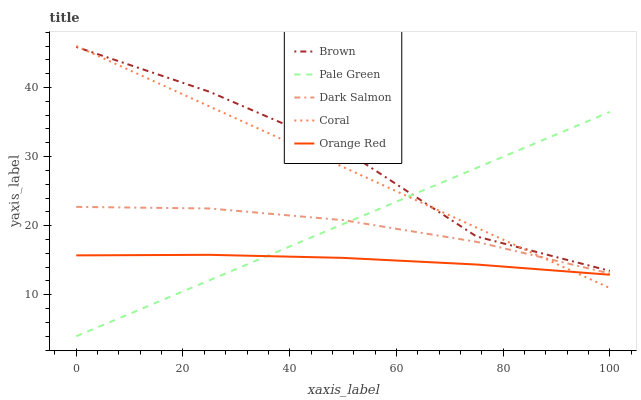Does Orange Red have the minimum area under the curve?
Answer yes or no. Yes. Does Brown have the maximum area under the curve?
Answer yes or no. Yes. Does Coral have the minimum area under the curve?
Answer yes or no. No. Does Coral have the maximum area under the curve?
Answer yes or no. No. Is Pale Green the smoothest?
Answer yes or no. Yes. Is Brown the roughest?
Answer yes or no. Yes. Is Coral the smoothest?
Answer yes or no. No. Is Coral the roughest?
Answer yes or no. No. Does Pale Green have the lowest value?
Answer yes or no. Yes. Does Coral have the lowest value?
Answer yes or no. No. Does Coral have the highest value?
Answer yes or no. Yes. Does Pale Green have the highest value?
Answer yes or no. No. Is Orange Red less than Brown?
Answer yes or no. Yes. Is Brown greater than Orange Red?
Answer yes or no. Yes. Does Dark Salmon intersect Coral?
Answer yes or no. Yes. Is Dark Salmon less than Coral?
Answer yes or no. No. Is Dark Salmon greater than Coral?
Answer yes or no. No. Does Orange Red intersect Brown?
Answer yes or no. No. 